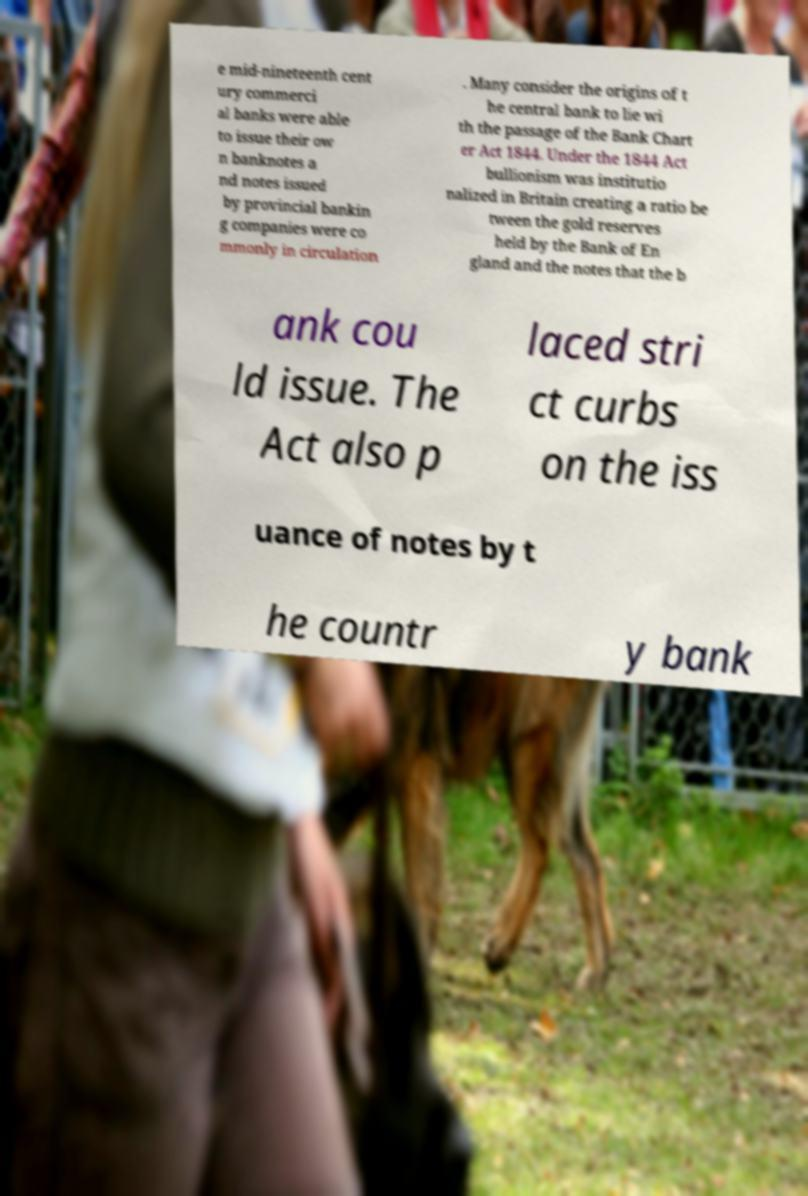For documentation purposes, I need the text within this image transcribed. Could you provide that? e mid-nineteenth cent ury commerci al banks were able to issue their ow n banknotes a nd notes issued by provincial bankin g companies were co mmonly in circulation . Many consider the origins of t he central bank to lie wi th the passage of the Bank Chart er Act 1844. Under the 1844 Act bullionism was institutio nalized in Britain creating a ratio be tween the gold reserves held by the Bank of En gland and the notes that the b ank cou ld issue. The Act also p laced stri ct curbs on the iss uance of notes by t he countr y bank 